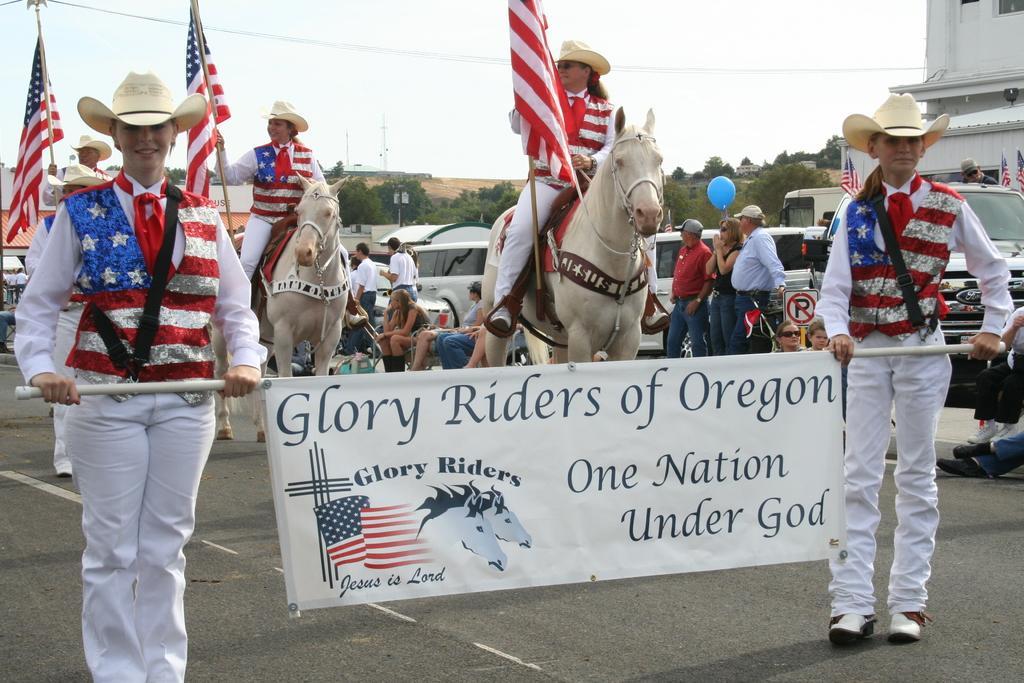In one or two sentences, can you explain what this image depicts? In this picture there are two people standing and holding the banner and there is text and there are pictures of horses and flags on the banner. At the back there are three people sitting on the horse and holding the flags. At the back there are group of people standing and there are group of people sitting and there are buildings and trees and there are vehicles. At the top there is sky. At the bottom there is a road. 